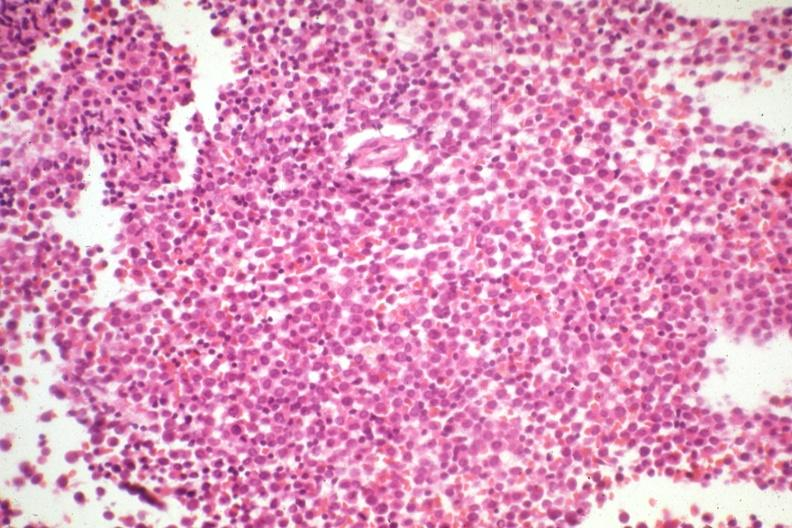what is present?
Answer the question using a single word or phrase. Bone marrow 